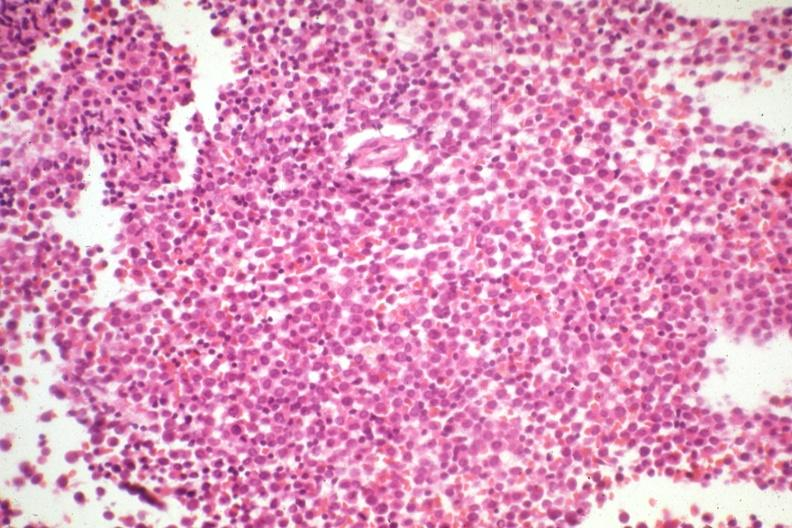what is present?
Answer the question using a single word or phrase. Bone marrow 